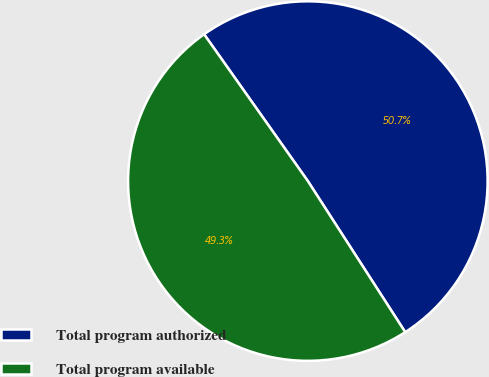<chart> <loc_0><loc_0><loc_500><loc_500><pie_chart><fcel>Total program authorized<fcel>Total program available<nl><fcel>50.68%<fcel>49.32%<nl></chart> 